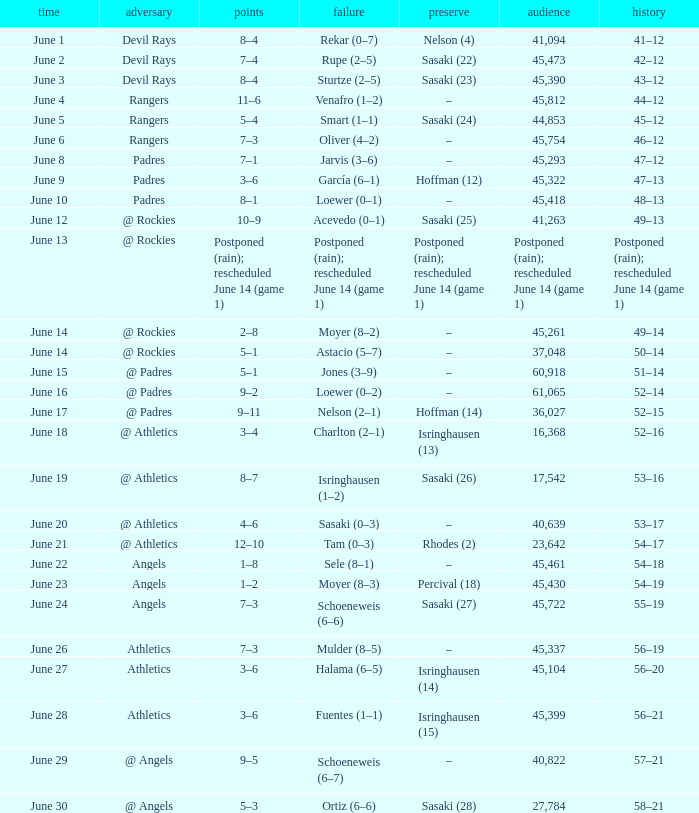What was the date of the Mariners game when they had a record of 53–17? June 20. 